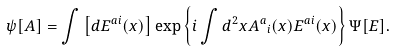<formula> <loc_0><loc_0><loc_500><loc_500>\psi [ A ] = \int \left [ d E ^ { a i } ( x ) \right ] \exp \left \{ i \int d ^ { 2 } x { A ^ { a } } _ { i } ( x ) E ^ { a i } ( x ) \right \} \Psi [ E ] .</formula> 